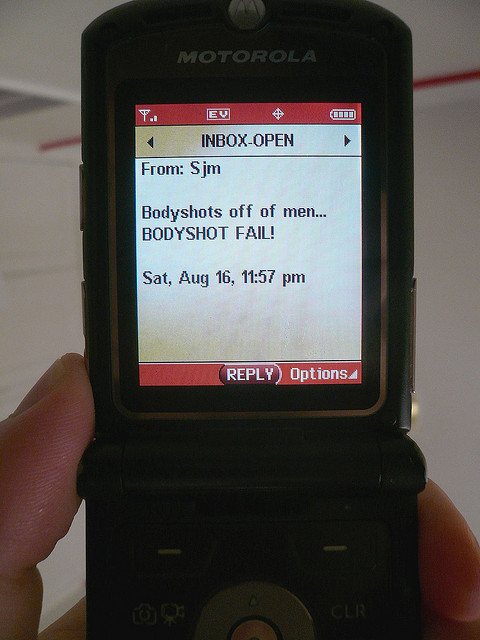Read all the text in this image. INBOX- OPEN From: Bodyshots FAIL! BODYSHOT MOTOROLA EV Options REPLY pm 57 11 16 Aug Sat men of off Sjm 